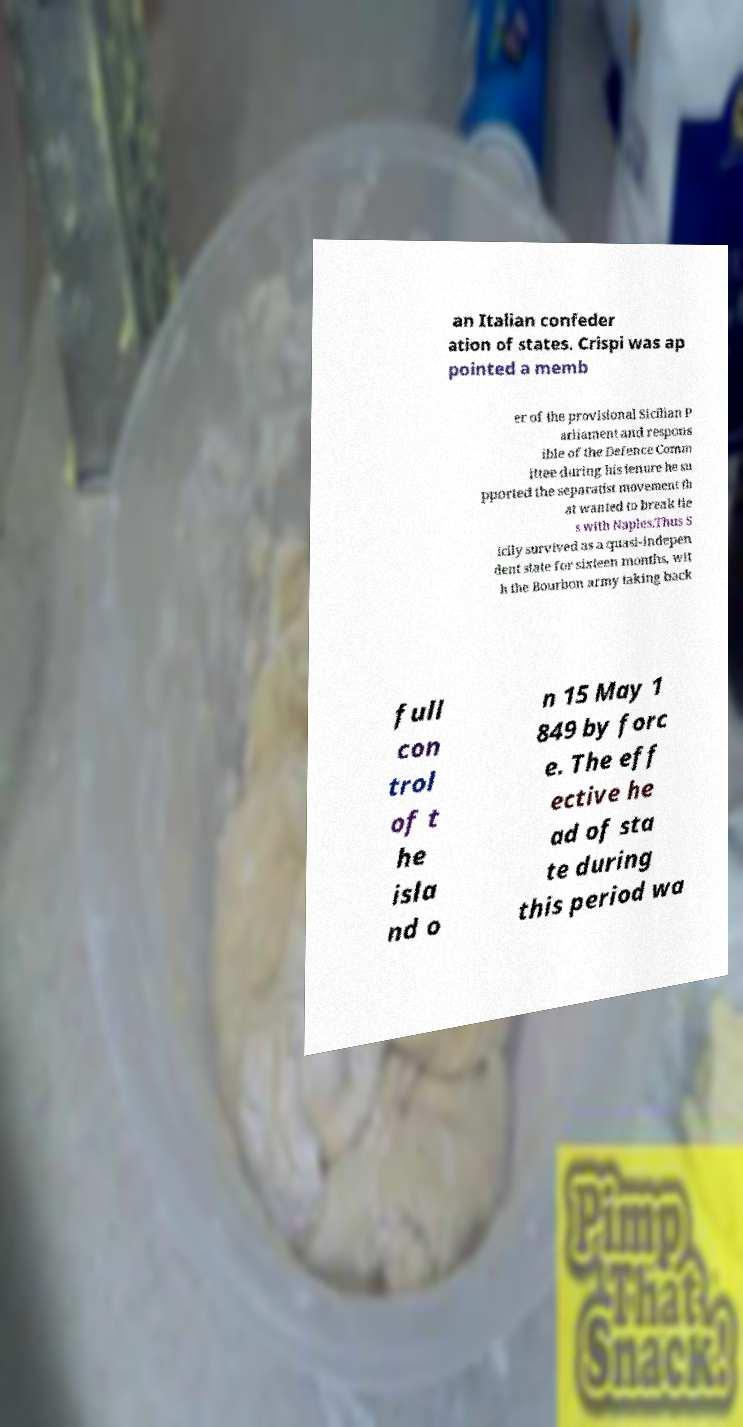There's text embedded in this image that I need extracted. Can you transcribe it verbatim? an Italian confeder ation of states. Crispi was ap pointed a memb er of the provisional Sicilian P arliament and respons ible of the Defence Comm ittee during his tenure he su pported the separatist movement th at wanted to break tie s with Naples.Thus S icily survived as a quasi-indepen dent state for sixteen months, wit h the Bourbon army taking back full con trol of t he isla nd o n 15 May 1 849 by forc e. The eff ective he ad of sta te during this period wa 